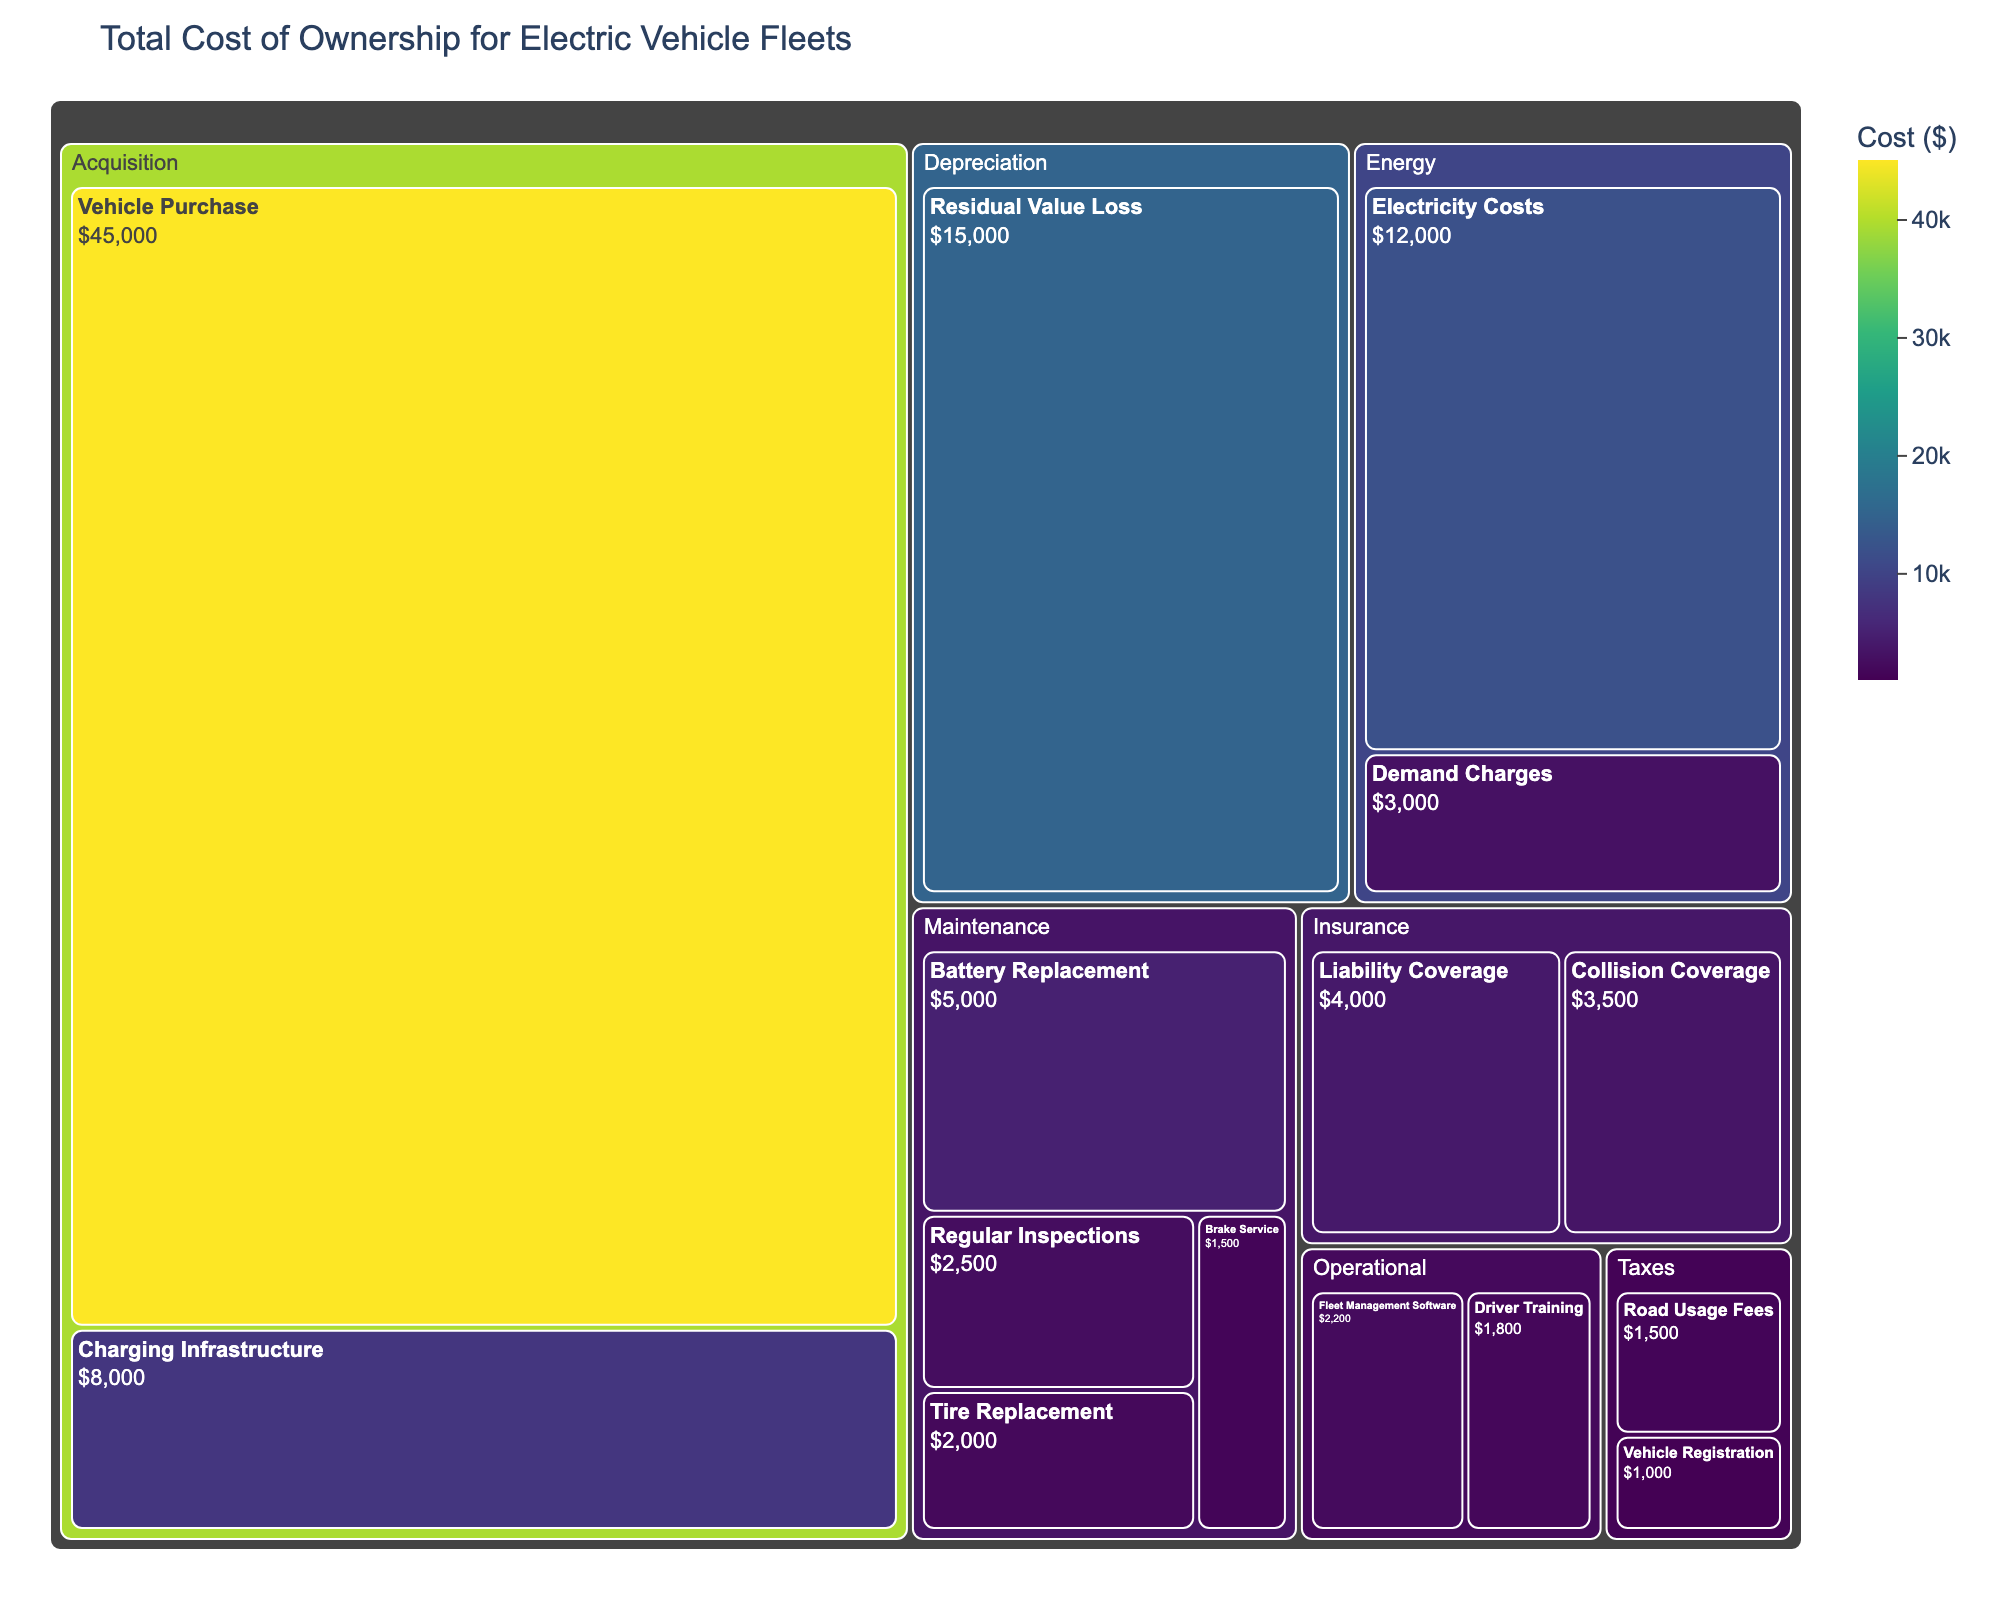What's the title of the figure? The title is placed at the top of the figure and specifies the topic or main subject of the visual representation.
Answer: Total Cost of Ownership for Electric Vehicle Fleets How much is the value for Vehicle Purchase under Acquisition? Look for the subcategory labeled "Vehicle Purchase" under the category "Acquisition" and read the value associated with it.
Answer: $45,000 Which category contains the highest cost item? Compare the values of the largest elements within each category. The one with the highest value will indicate the category with the highest cost item.
Answer: Acquisition What is the combined cost for all Maintenance subcategories? Add the values of all subcategories under Maintenance: Battery Replacement ($5,000) + Tire Replacement ($2,000) + Brake Service ($1,500) + Regular Inspections ($2,500).
Answer: $11,000 How does the cost of Electricity compare to Demand Charges? Compare the values of "Electricity Costs" and "Demand Charges" under the Energy category.
Answer: Electricity Costs are higher Which insurance subcategory has a higher cost, Liability Coverage or Collision Coverage? Compare the values of "Liability Coverage" and "Collision Coverage" under the Insurance category.
Answer: Liability Coverage What is the total cost for Operational expenses? Add the values of the subcategories under Operational: Driver Training ($1,800) + Fleet Management Software ($2,200).
Answer: $4,000 What is the cost difference between the highest and lowest cost subcategories? Identify the highest and lowest cost subcategories by scanning all values, then calculate the difference: Vehicle Purchase ($45,000) - Vehicle Registration ($1,000).
Answer: $44,000 Which category has the smallest total cost? Sum the values of each category to find which has the lowest total.
Answer: Taxes 